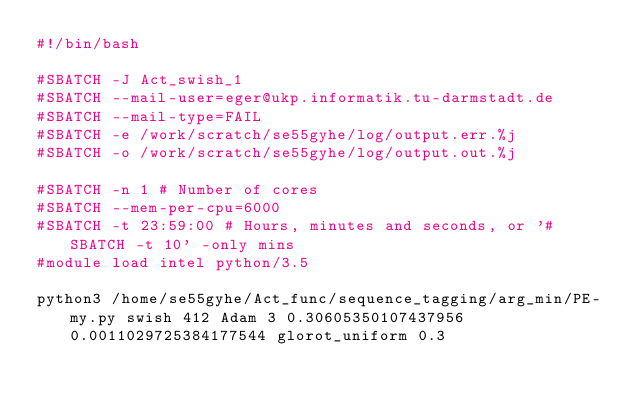Convert code to text. <code><loc_0><loc_0><loc_500><loc_500><_Bash_>#!/bin/bash
 
#SBATCH -J Act_swish_1
#SBATCH --mail-user=eger@ukp.informatik.tu-darmstadt.de
#SBATCH --mail-type=FAIL
#SBATCH -e /work/scratch/se55gyhe/log/output.err.%j
#SBATCH -o /work/scratch/se55gyhe/log/output.out.%j

#SBATCH -n 1 # Number of cores
#SBATCH --mem-per-cpu=6000
#SBATCH -t 23:59:00 # Hours, minutes and seconds, or '#SBATCH -t 10' -only mins
#module load intel python/3.5

python3 /home/se55gyhe/Act_func/sequence_tagging/arg_min/PE-my.py swish 412 Adam 3 0.30605350107437956 0.0011029725384177544 glorot_uniform 0.3

</code> 